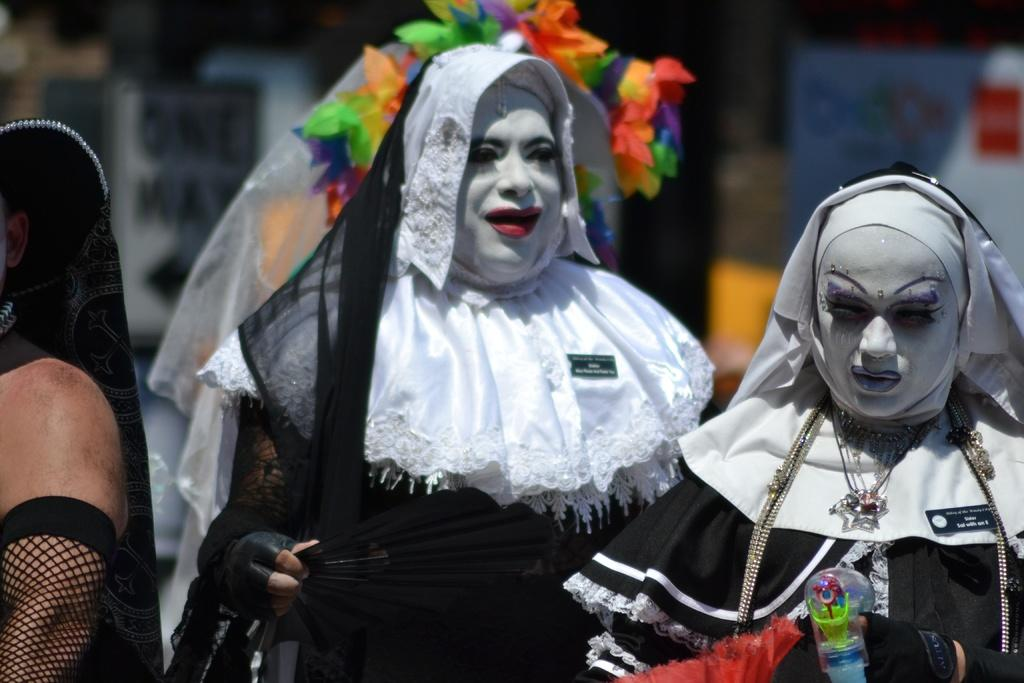What is happening in the center of the image? There are persons standing in the center of the image. What are the persons wearing? The persons are wearing costumes. Can you describe the background of the image? The background of the image is blurry. How many buttons can be seen on the costumes of the persons in the image? There is no information about buttons on the costumes in the provided facts, so it cannot be determined from the image. 